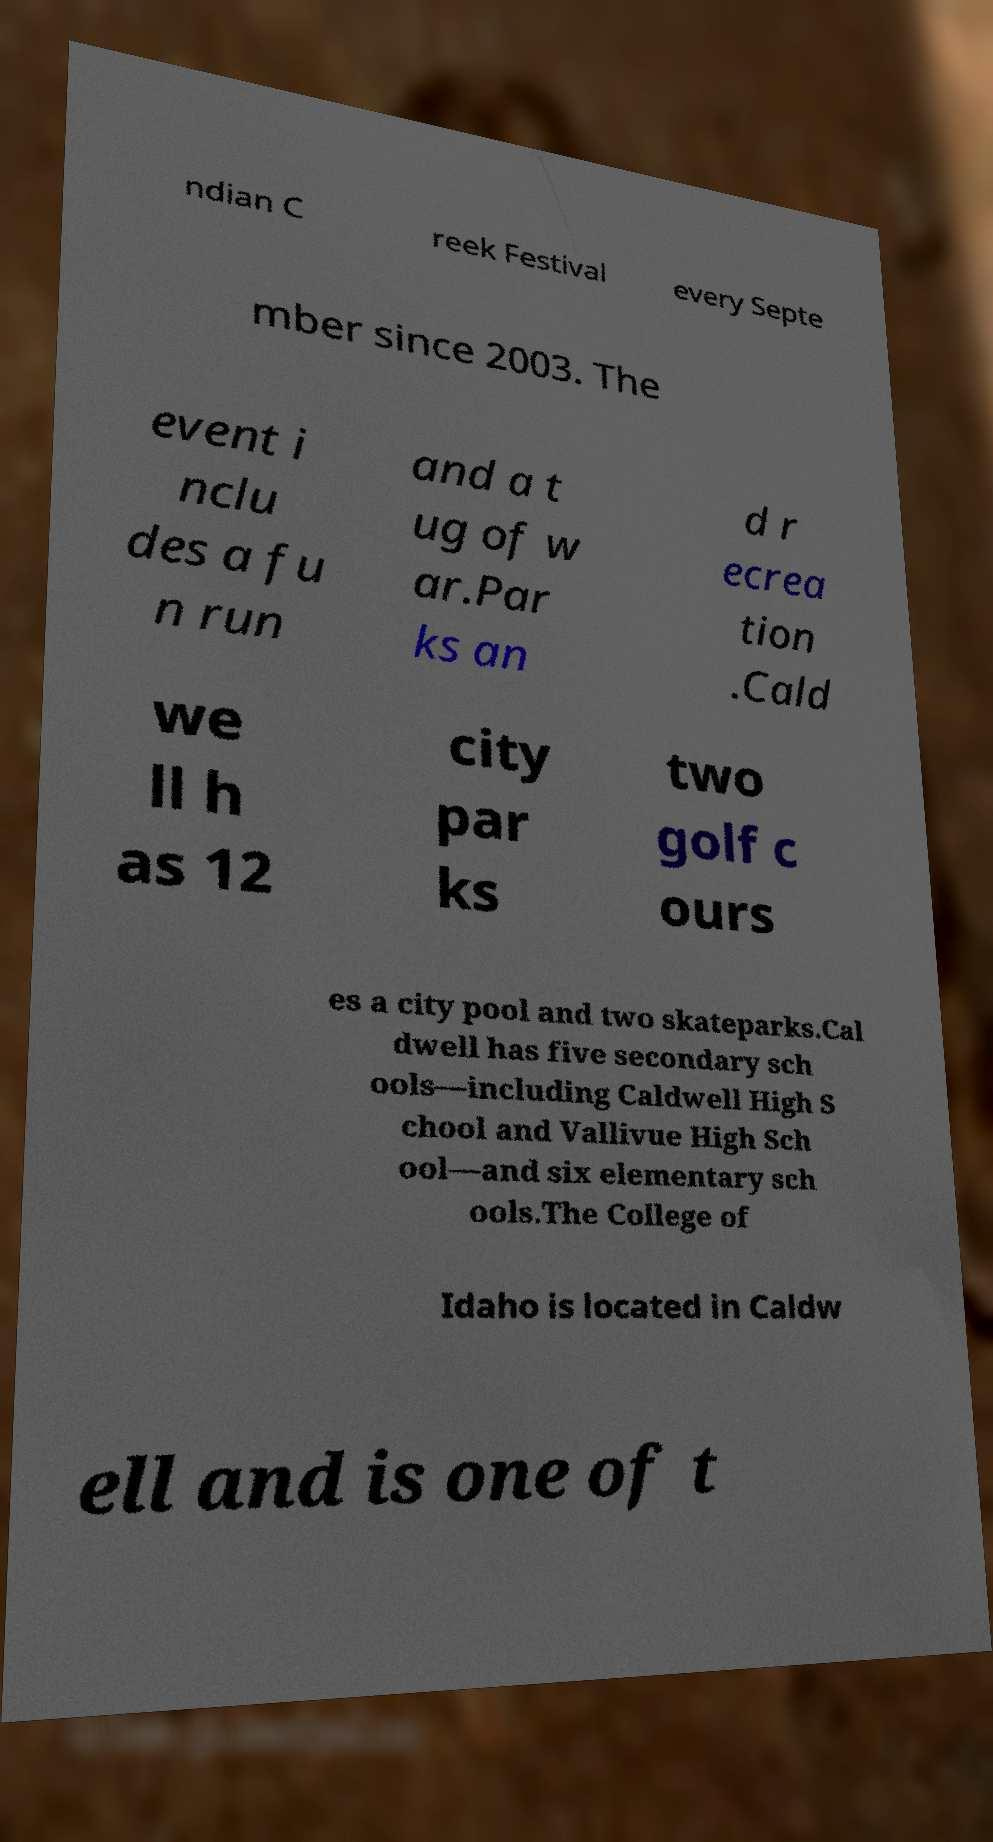Please identify and transcribe the text found in this image. ndian C reek Festival every Septe mber since 2003. The event i nclu des a fu n run and a t ug of w ar.Par ks an d r ecrea tion .Cald we ll h as 12 city par ks two golf c ours es a city pool and two skateparks.Cal dwell has five secondary sch ools—including Caldwell High S chool and Vallivue High Sch ool—and six elementary sch ools.The College of Idaho is located in Caldw ell and is one of t 